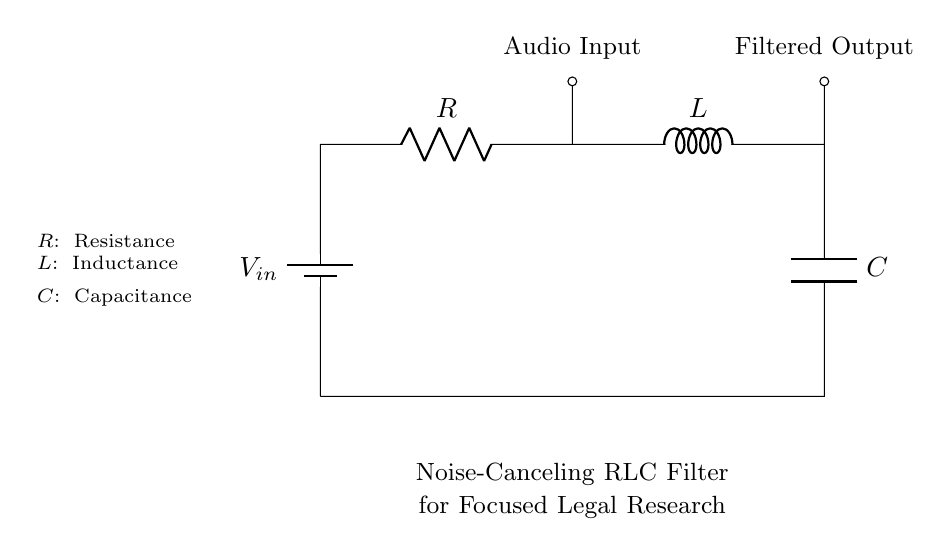What type of components are in this circuit? The circuit contains three types of components: a resistor, an inductor, and a capacitor. These components are standard for an RLC circuit and are indicated in the diagram with their labels.
Answer: Resistor, Inductor, Capacitor What is the primary function of the RLC filter in this circuit? The primary function of the RLC filter in this circuit is to cancel noise, thereby improving audio quality for focused listening. The filter allows certain frequencies to pass while attenuating others, making it suitable for noise-canceling applications.
Answer: Noise cancellation What voltage is applied to the circuit? The voltage applied to the circuit is denoted as V_in, which is indicated at the top of the circuit diagram. There are no specific numerical values given for V_in in the diagram, just a label.
Answer: V_in What happens to the audio input at the filtered output? The audio input signal is modified as it passes through the RLC filter, resulting in a filtered output where unwanted frequencies are reduced significantly, allowing for clearer listening. The filtered output is shown at the bottom of the circuit diagram.
Answer: Modified signal How does increasing the resistance affect the RLC filter's performance? Increasing the resistance will affect the damping of the circuit, leading to a decrease in the sharpness of resonance. Higher resistance typically reduces the amplitude of the response at resonance, which can potentially impact the effectiveness of noise cancellation depending on the desired outcome.
Answer: Decreases sharpness What is the resonance frequency for this RLC circuit? The resonance frequency is determined by the values of the inductor (L) and capacitor (C) in the circuit, typically calculated using the formula 1 over 2 pi times the square root of L times C. The diagram does not provide specific values, so the exact numerical answer cannot be given.
Answer: 1/(2π√(LC)) 